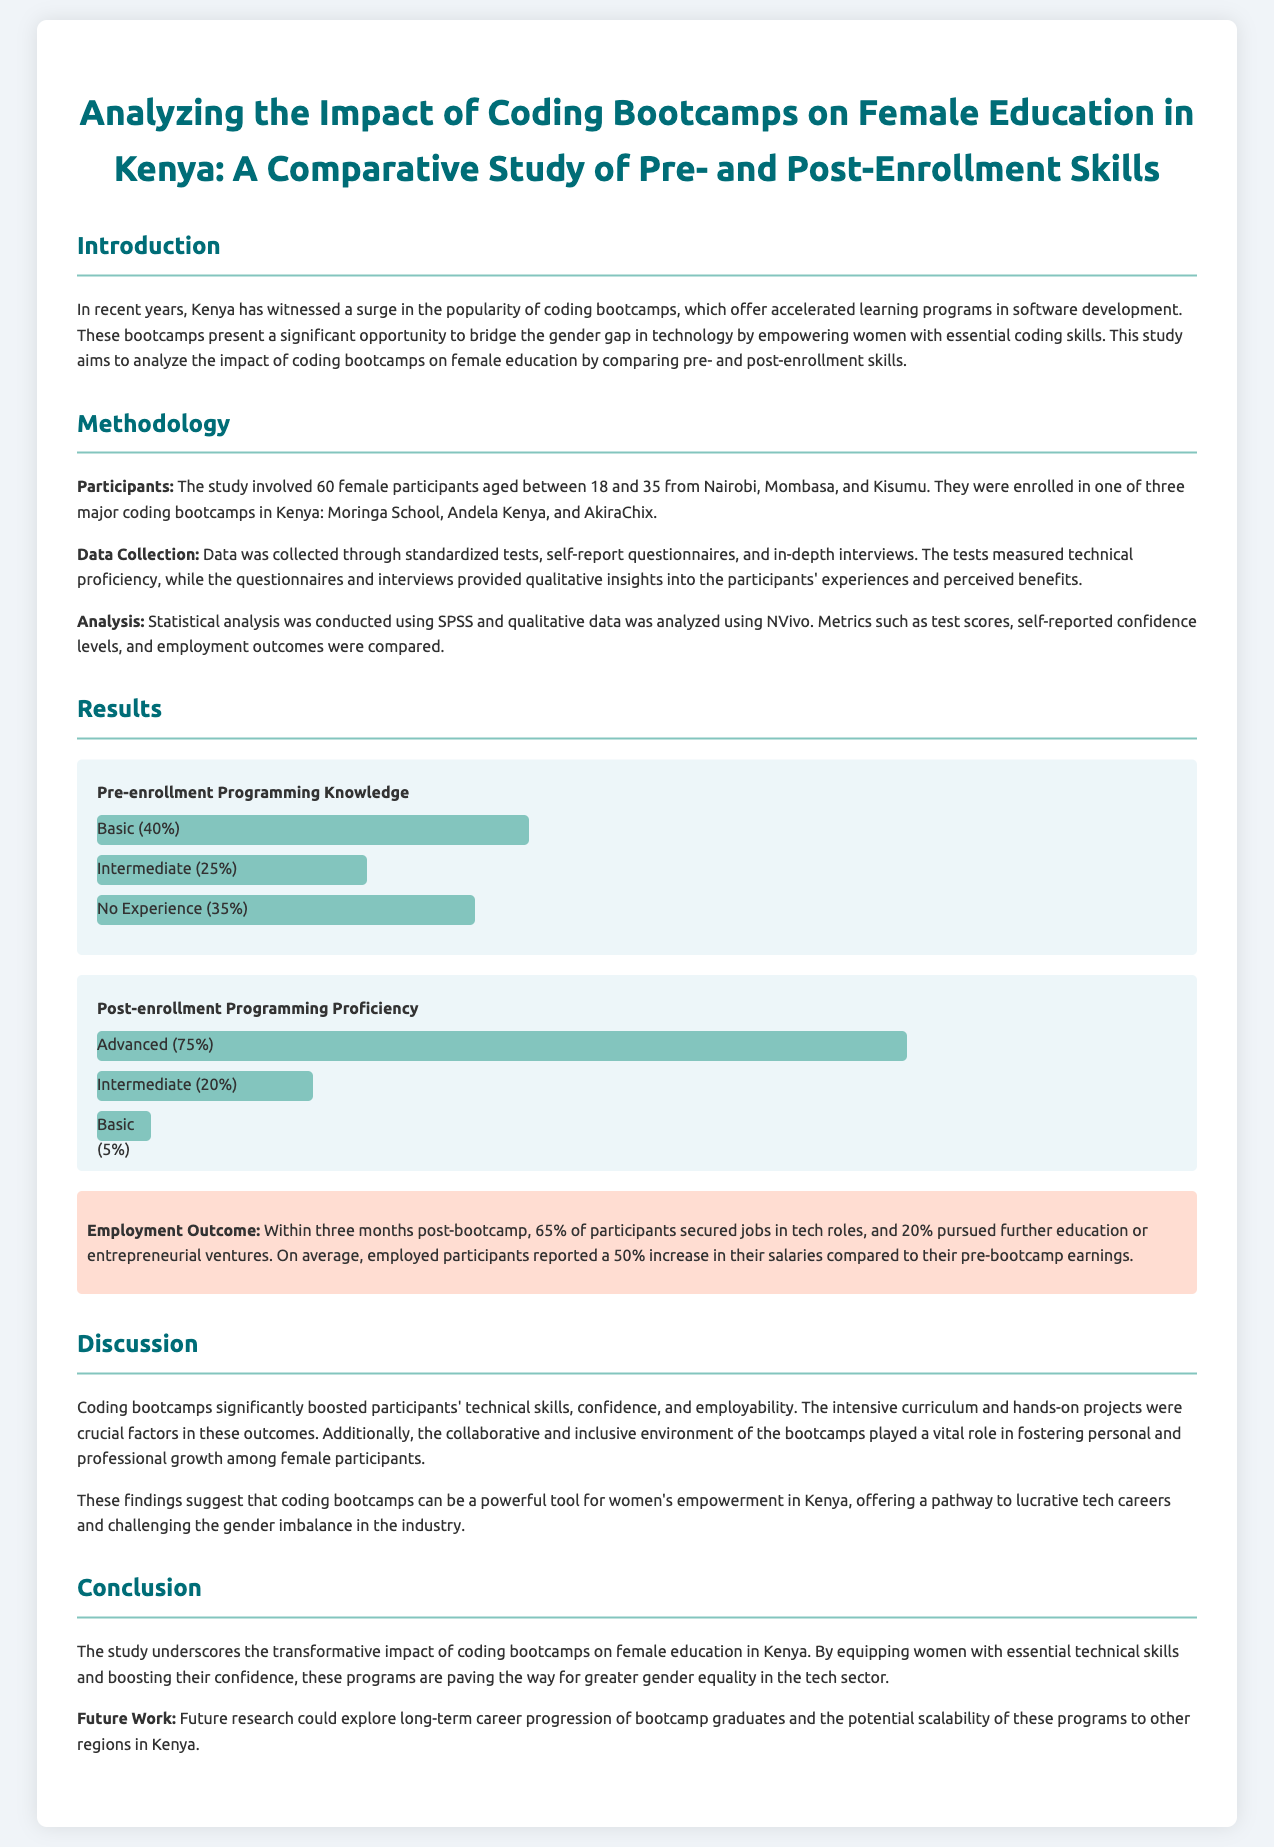What was the sample size of female participants? The study involved 60 female participants aged between 18 and 35 from Nairobi, Mombasa, and Kisumu.
Answer: 60 What was the post-enrollment percentage of participants with advanced programming proficiency? The results show that 75% of participants had advanced programming proficiency after enrollment.
Answer: 75% Which three coding bootcamps were involved in the study? The study focuses on Moringa School, Andela Kenya, and AkiraChix.
Answer: Moringa School, Andela Kenya, AkiraChix What percentage of participants secured jobs within three months post-bootcamp? The document states that 65% of participants secured jobs in tech roles within three months.
Answer: 65% What analysis software was used for statistical analysis? Statistical analysis was conducted using SPSS.
Answer: SPSS How much did employed participants report their salary increase on average? Employed participants reported a 50% increase in their salaries post-bootcamp compared to pre-bootcamp earnings.
Answer: 50% What was noted as a crucial factor for participants' outcomes? The intensive curriculum and hands-on projects were crucial factors in the outcomes of participants.
Answer: Intensive curriculum and hands-on projects What did the study suggest about coding bootcamps for women's empowerment in Kenya? The findings suggest that coding bootcamps can be a powerful tool for women's empowerment in Kenya.
Answer: Powerful tool for women's empowerment 